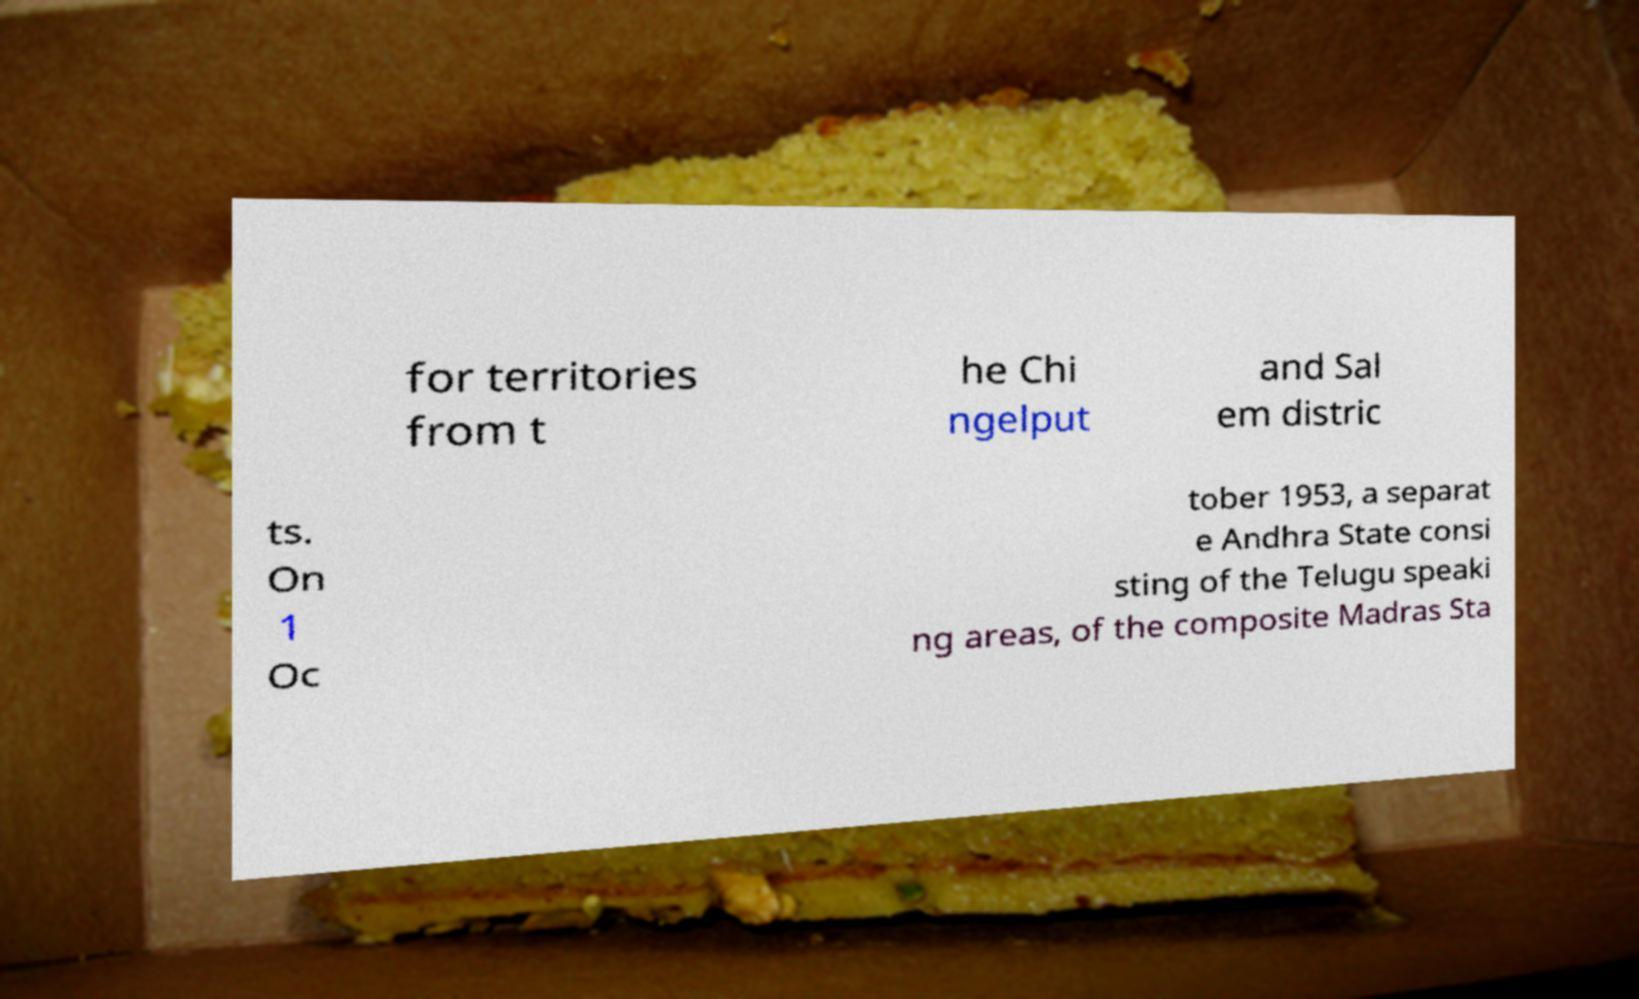I need the written content from this picture converted into text. Can you do that? for territories from t he Chi ngelput and Sal em distric ts. On 1 Oc tober 1953, a separat e Andhra State consi sting of the Telugu speaki ng areas, of the composite Madras Sta 